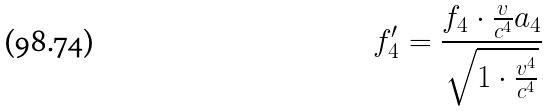<formula> <loc_0><loc_0><loc_500><loc_500>f _ { 4 } ^ { \prime } = \frac { f _ { 4 } \cdot \frac { v } { c ^ { 4 } } a _ { 4 } } { \sqrt { 1 \cdot \frac { v ^ { 4 } } { c ^ { 4 } } } }</formula> 